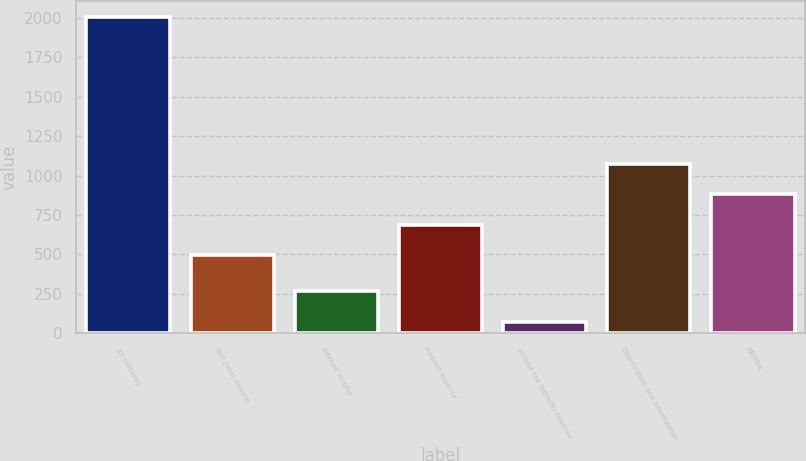Convert chart. <chart><loc_0><loc_0><loc_500><loc_500><bar_chart><fcel>(in millions)<fcel>Net (loss) income<fcel>Interest income<fcel>Interest expense<fcel>Income tax (benefit) expense<fcel>Depreciation and amortization<fcel>EBITDA<nl><fcel>2007<fcel>495<fcel>267.3<fcel>688.3<fcel>74<fcel>1074.9<fcel>881.6<nl></chart> 